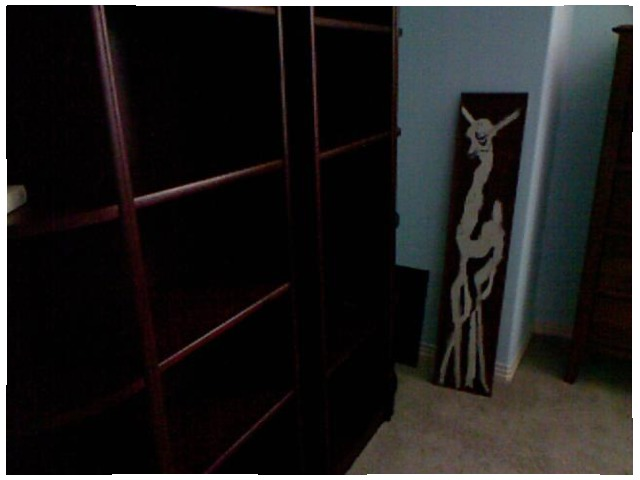<image>
Is there a shelf in front of the picture? Yes. The shelf is positioned in front of the picture, appearing closer to the camera viewpoint. Is the picture behind the wall? No. The picture is not behind the wall. From this viewpoint, the picture appears to be positioned elsewhere in the scene. 